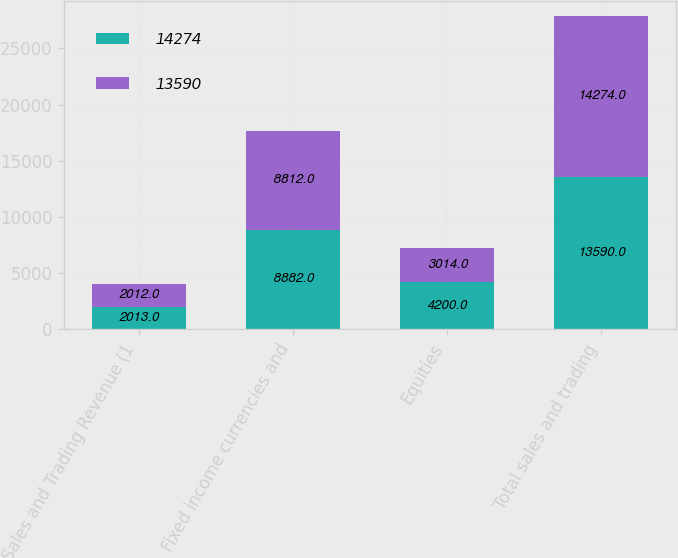Convert chart to OTSL. <chart><loc_0><loc_0><loc_500><loc_500><stacked_bar_chart><ecel><fcel>Sales and Trading Revenue (1<fcel>Fixed income currencies and<fcel>Equities<fcel>Total sales and trading<nl><fcel>14274<fcel>2013<fcel>8882<fcel>4200<fcel>13590<nl><fcel>13590<fcel>2012<fcel>8812<fcel>3014<fcel>14274<nl></chart> 